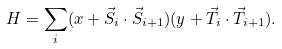Convert formula to latex. <formula><loc_0><loc_0><loc_500><loc_500>H = \sum _ { i } ( x + { \vec { S } } _ { i } \cdot { \vec { S } } _ { i + 1 } ) ( y + { \vec { T } } _ { i } \cdot { \vec { T } } _ { i + 1 } ) .</formula> 